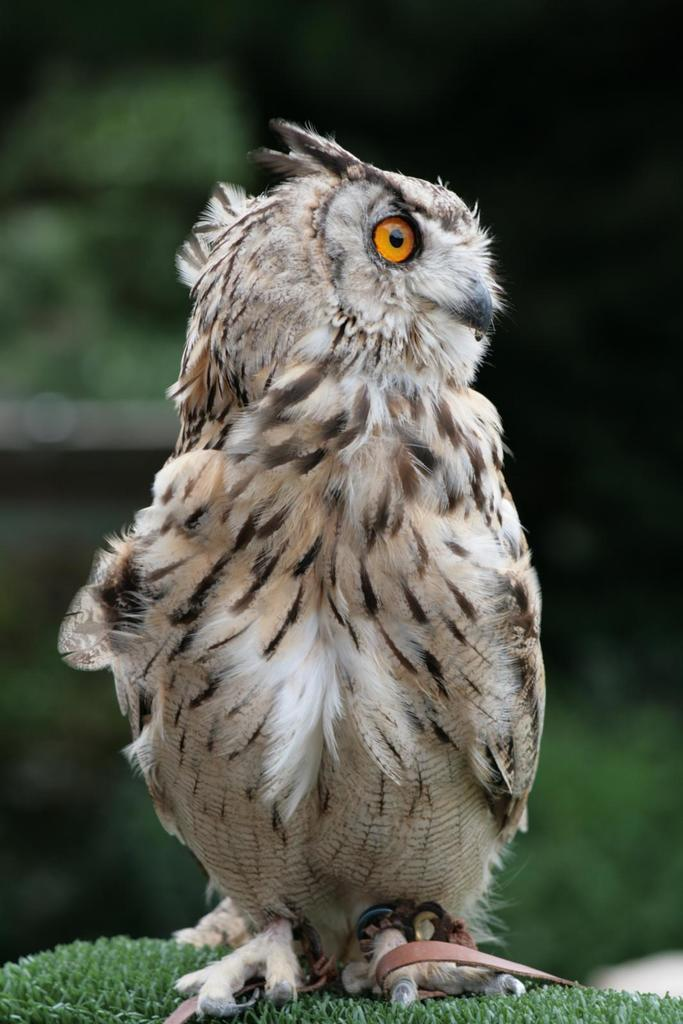What type of animal is in the image? There is an owl in the image. Where is the owl located? The owl is on the grass. Can you describe the background of the image? The background of the image is blurred. What time of day is the owl participating in a morning competition in the image? There is no mention of a morning competition or any specific time of day in the image. 